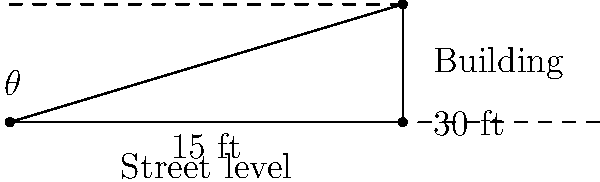As a small-business owner planning to install a rooftop advertisement, you need to determine the angle of elevation for optimal visibility from street level. Given that the building is 30 feet tall and a person standing 15 feet away from the building can see the top of the advertisement, what is the angle of elevation ($\theta$) in degrees? To find the angle of elevation, we can use basic trigonometry:

1. Identify the right triangle formed by the line of sight, the building, and the ground.
2. The adjacent side of the triangle is the distance from the person to the building (15 feet).
3. The opposite side is the height of the building (30 feet).
4. We can use the tangent function to find the angle:

   $\tan(\theta) = \frac{\text{opposite}}{\text{adjacent}} = \frac{30}{15} = 2$

5. To find $\theta$, we need to use the inverse tangent (arctan) function:

   $\theta = \arctan(2)$

6. Using a calculator or trigonometric tables:

   $\theta \approx 63.43^\circ$

7. Rounding to the nearest degree:

   $\theta \approx 63^\circ$

This angle ensures that the rooftop advertisement will be visible from the specified distance on street level, complying with local advertising regulations.
Answer: $63^\circ$ 